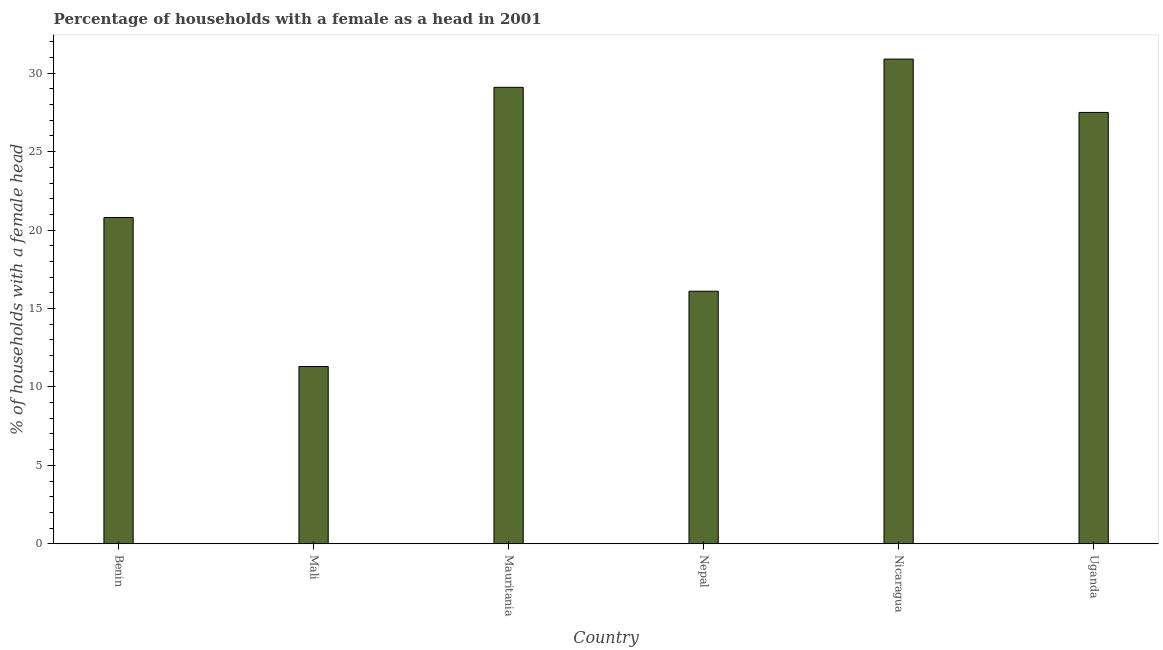What is the title of the graph?
Your answer should be compact. Percentage of households with a female as a head in 2001. What is the label or title of the X-axis?
Provide a short and direct response. Country. What is the label or title of the Y-axis?
Your response must be concise. % of households with a female head. Across all countries, what is the maximum number of female supervised households?
Make the answer very short. 30.9. In which country was the number of female supervised households maximum?
Your response must be concise. Nicaragua. In which country was the number of female supervised households minimum?
Your response must be concise. Mali. What is the sum of the number of female supervised households?
Keep it short and to the point. 135.7. What is the difference between the number of female supervised households in Mali and Mauritania?
Keep it short and to the point. -17.8. What is the average number of female supervised households per country?
Provide a succinct answer. 22.62. What is the median number of female supervised households?
Give a very brief answer. 24.15. In how many countries, is the number of female supervised households greater than 17 %?
Provide a succinct answer. 4. What is the ratio of the number of female supervised households in Mali to that in Nicaragua?
Ensure brevity in your answer.  0.37. Is the difference between the number of female supervised households in Mauritania and Uganda greater than the difference between any two countries?
Your answer should be very brief. No. What is the difference between the highest and the second highest number of female supervised households?
Your answer should be compact. 1.8. Is the sum of the number of female supervised households in Nepal and Uganda greater than the maximum number of female supervised households across all countries?
Offer a very short reply. Yes. What is the difference between the highest and the lowest number of female supervised households?
Your answer should be compact. 19.6. In how many countries, is the number of female supervised households greater than the average number of female supervised households taken over all countries?
Make the answer very short. 3. How many bars are there?
Provide a succinct answer. 6. How many countries are there in the graph?
Provide a succinct answer. 6. What is the difference between two consecutive major ticks on the Y-axis?
Ensure brevity in your answer.  5. Are the values on the major ticks of Y-axis written in scientific E-notation?
Your response must be concise. No. What is the % of households with a female head of Benin?
Make the answer very short. 20.8. What is the % of households with a female head in Mali?
Provide a short and direct response. 11.3. What is the % of households with a female head in Mauritania?
Give a very brief answer. 29.1. What is the % of households with a female head in Nepal?
Provide a short and direct response. 16.1. What is the % of households with a female head of Nicaragua?
Provide a succinct answer. 30.9. What is the difference between the % of households with a female head in Benin and Mali?
Keep it short and to the point. 9.5. What is the difference between the % of households with a female head in Benin and Mauritania?
Your answer should be very brief. -8.3. What is the difference between the % of households with a female head in Benin and Nicaragua?
Keep it short and to the point. -10.1. What is the difference between the % of households with a female head in Benin and Uganda?
Make the answer very short. -6.7. What is the difference between the % of households with a female head in Mali and Mauritania?
Offer a very short reply. -17.8. What is the difference between the % of households with a female head in Mali and Nepal?
Make the answer very short. -4.8. What is the difference between the % of households with a female head in Mali and Nicaragua?
Your answer should be compact. -19.6. What is the difference between the % of households with a female head in Mali and Uganda?
Give a very brief answer. -16.2. What is the difference between the % of households with a female head in Mauritania and Nepal?
Ensure brevity in your answer.  13. What is the difference between the % of households with a female head in Mauritania and Uganda?
Keep it short and to the point. 1.6. What is the difference between the % of households with a female head in Nepal and Nicaragua?
Provide a succinct answer. -14.8. What is the difference between the % of households with a female head in Nicaragua and Uganda?
Provide a succinct answer. 3.4. What is the ratio of the % of households with a female head in Benin to that in Mali?
Offer a terse response. 1.84. What is the ratio of the % of households with a female head in Benin to that in Mauritania?
Your answer should be compact. 0.71. What is the ratio of the % of households with a female head in Benin to that in Nepal?
Ensure brevity in your answer.  1.29. What is the ratio of the % of households with a female head in Benin to that in Nicaragua?
Your answer should be compact. 0.67. What is the ratio of the % of households with a female head in Benin to that in Uganda?
Provide a succinct answer. 0.76. What is the ratio of the % of households with a female head in Mali to that in Mauritania?
Make the answer very short. 0.39. What is the ratio of the % of households with a female head in Mali to that in Nepal?
Offer a very short reply. 0.7. What is the ratio of the % of households with a female head in Mali to that in Nicaragua?
Offer a terse response. 0.37. What is the ratio of the % of households with a female head in Mali to that in Uganda?
Give a very brief answer. 0.41. What is the ratio of the % of households with a female head in Mauritania to that in Nepal?
Provide a short and direct response. 1.81. What is the ratio of the % of households with a female head in Mauritania to that in Nicaragua?
Make the answer very short. 0.94. What is the ratio of the % of households with a female head in Mauritania to that in Uganda?
Your answer should be compact. 1.06. What is the ratio of the % of households with a female head in Nepal to that in Nicaragua?
Give a very brief answer. 0.52. What is the ratio of the % of households with a female head in Nepal to that in Uganda?
Your answer should be very brief. 0.58. What is the ratio of the % of households with a female head in Nicaragua to that in Uganda?
Your response must be concise. 1.12. 